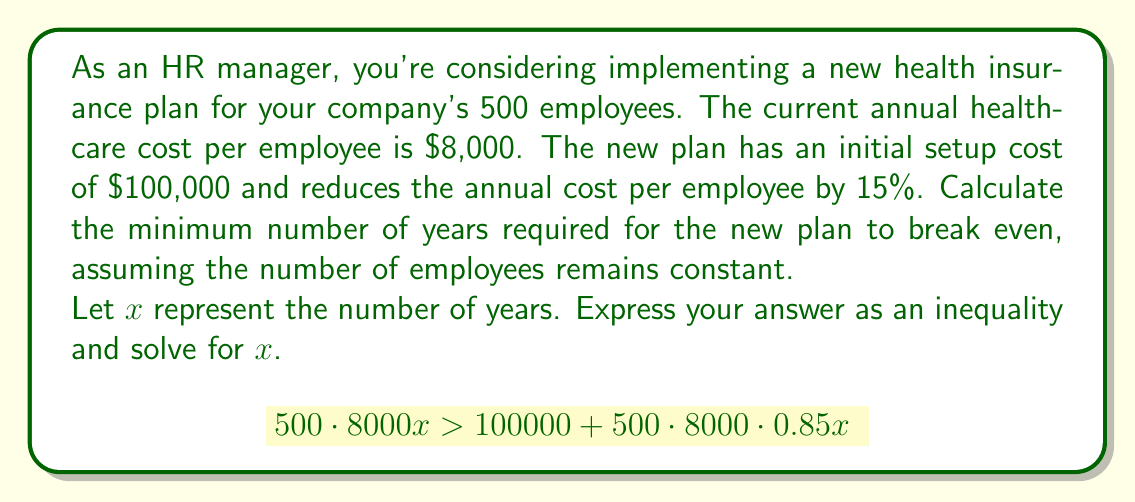Give your solution to this math problem. To solve this problem, we'll follow these steps:

1) First, let's set up the inequality:
   (Cost of old plan over x years) > (Setup cost + Cost of new plan over x years)
   
   $$500 \cdot 8000x > 100000 + 500 \cdot 8000 \cdot 0.85x$$

2) Simplify the right side of the inequality:
   $$4000000x > 100000 + 3400000x$$

3) Subtract 3400000x from both sides:
   $$600000x > 100000$$

4) Divide both sides by 600000:
   $$x > \frac{100000}{600000}$$

5) Simplify the fraction:
   $$x > \frac{1}{6}$$

6) Since we're dealing with years, we need to round up to the nearest whole number. The smallest integer greater than $\frac{1}{6}$ is 1.

Therefore, the new plan will break even after 1 year.
Answer: $x > \frac{1}{6}$, so the minimum number of years required for the new plan to break even is 1 year. 